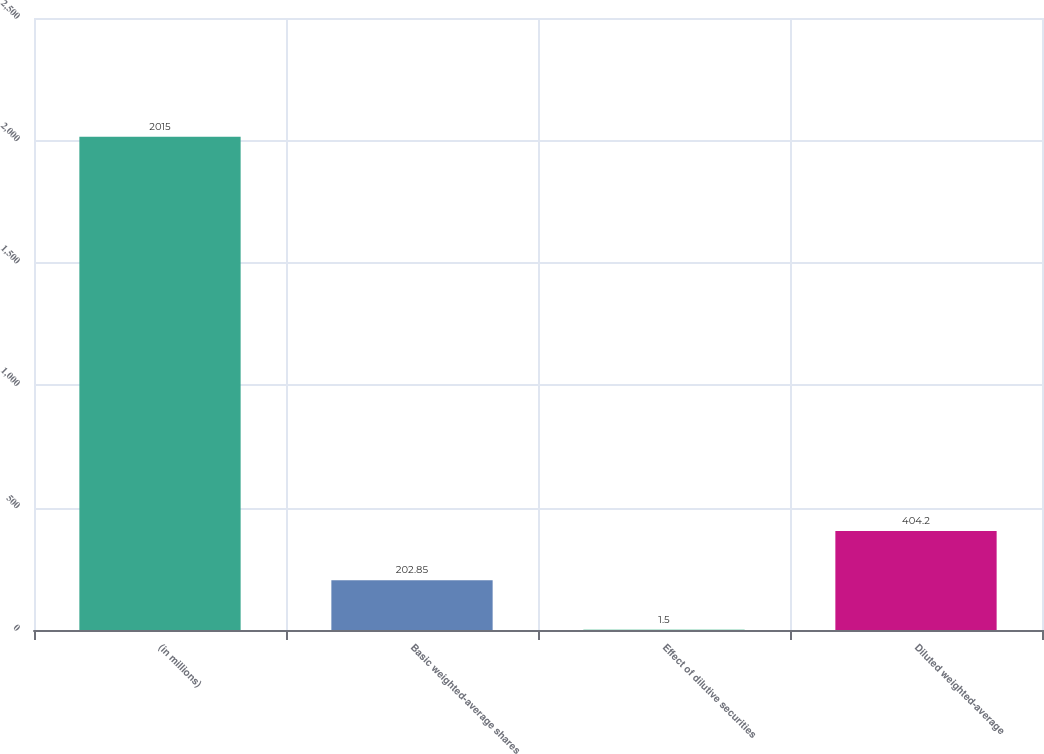Convert chart. <chart><loc_0><loc_0><loc_500><loc_500><bar_chart><fcel>(in millions)<fcel>Basic weighted-average shares<fcel>Effect of dilutive securities<fcel>Diluted weighted-average<nl><fcel>2015<fcel>202.85<fcel>1.5<fcel>404.2<nl></chart> 